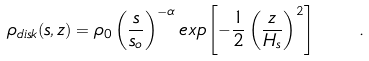Convert formula to latex. <formula><loc_0><loc_0><loc_500><loc_500>\rho _ { d i s k } ( s , z ) = \rho _ { 0 } \left ( \frac { s } { s _ { o } } \right ) ^ { - \alpha } e x p \left [ - \frac { 1 } { 2 } \left ( \frac { z } { H _ { s } } \right ) ^ { 2 } \right ] \quad .</formula> 